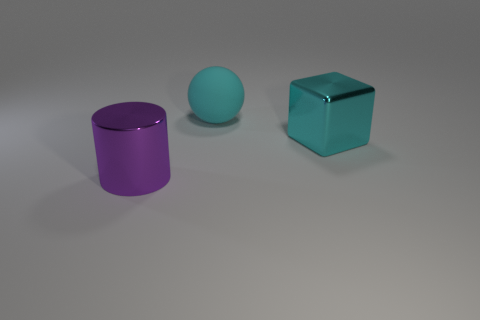Are there any other things that are the same shape as the cyan rubber thing?
Make the answer very short. No. Is the number of purple cylinders on the right side of the large cyan matte ball less than the number of large cyan spheres that are in front of the large shiny cube?
Provide a succinct answer. No. Is the block made of the same material as the big purple object?
Your response must be concise. Yes. There is a object that is in front of the cyan matte ball and to the right of the purple cylinder; what is its size?
Your response must be concise. Large. What shape is the cyan metal thing that is the same size as the rubber ball?
Offer a very short reply. Cube. The thing that is behind the big shiny object that is behind the shiny object that is to the left of the shiny cube is made of what material?
Provide a short and direct response. Rubber. There is a big metal object that is on the right side of the purple cylinder; does it have the same shape as the big thing left of the matte thing?
Your answer should be compact. No. How many other objects are the same material as the big cylinder?
Provide a short and direct response. 1. Is the material of the large thing that is on the right side of the large sphere the same as the big thing that is to the left of the ball?
Offer a terse response. Yes. The purple object that is made of the same material as the cyan block is what shape?
Keep it short and to the point. Cylinder. 